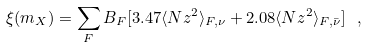<formula> <loc_0><loc_0><loc_500><loc_500>\xi ( m _ { X } ) = \sum _ { F } B _ { F } [ 3 . 4 7 \langle N z ^ { 2 } \rangle _ { F , \nu } + 2 . 0 8 \langle N z ^ { 2 } \rangle _ { F , \bar { \nu } } ] \ ,</formula> 